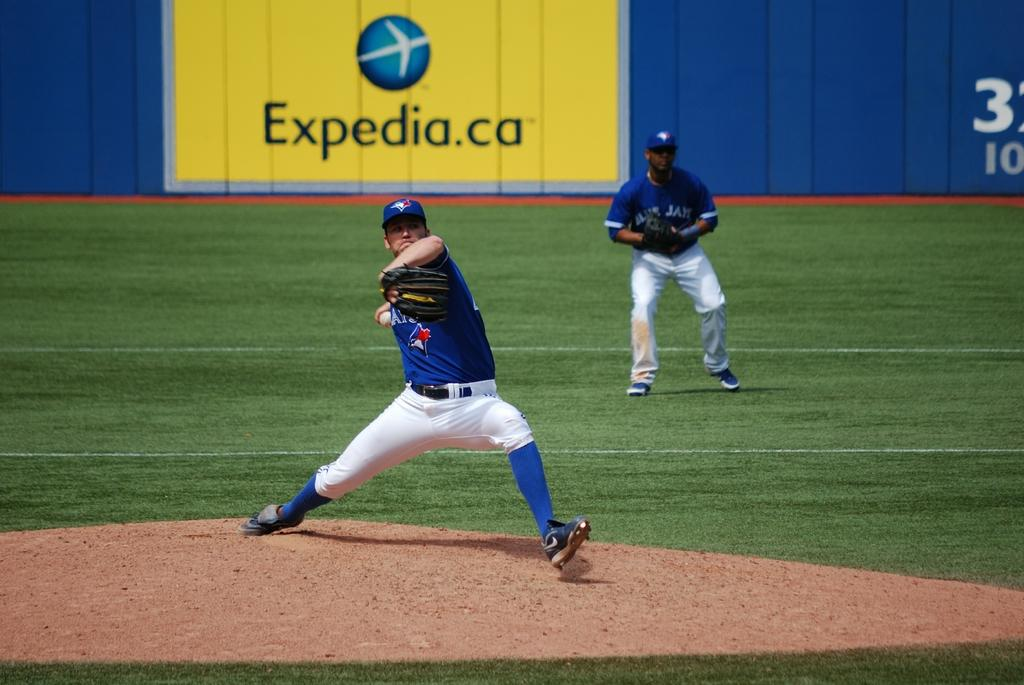<image>
Share a concise interpretation of the image provided. A baseball pitching is throwing the ball with an advertising for Expedia in the background. 